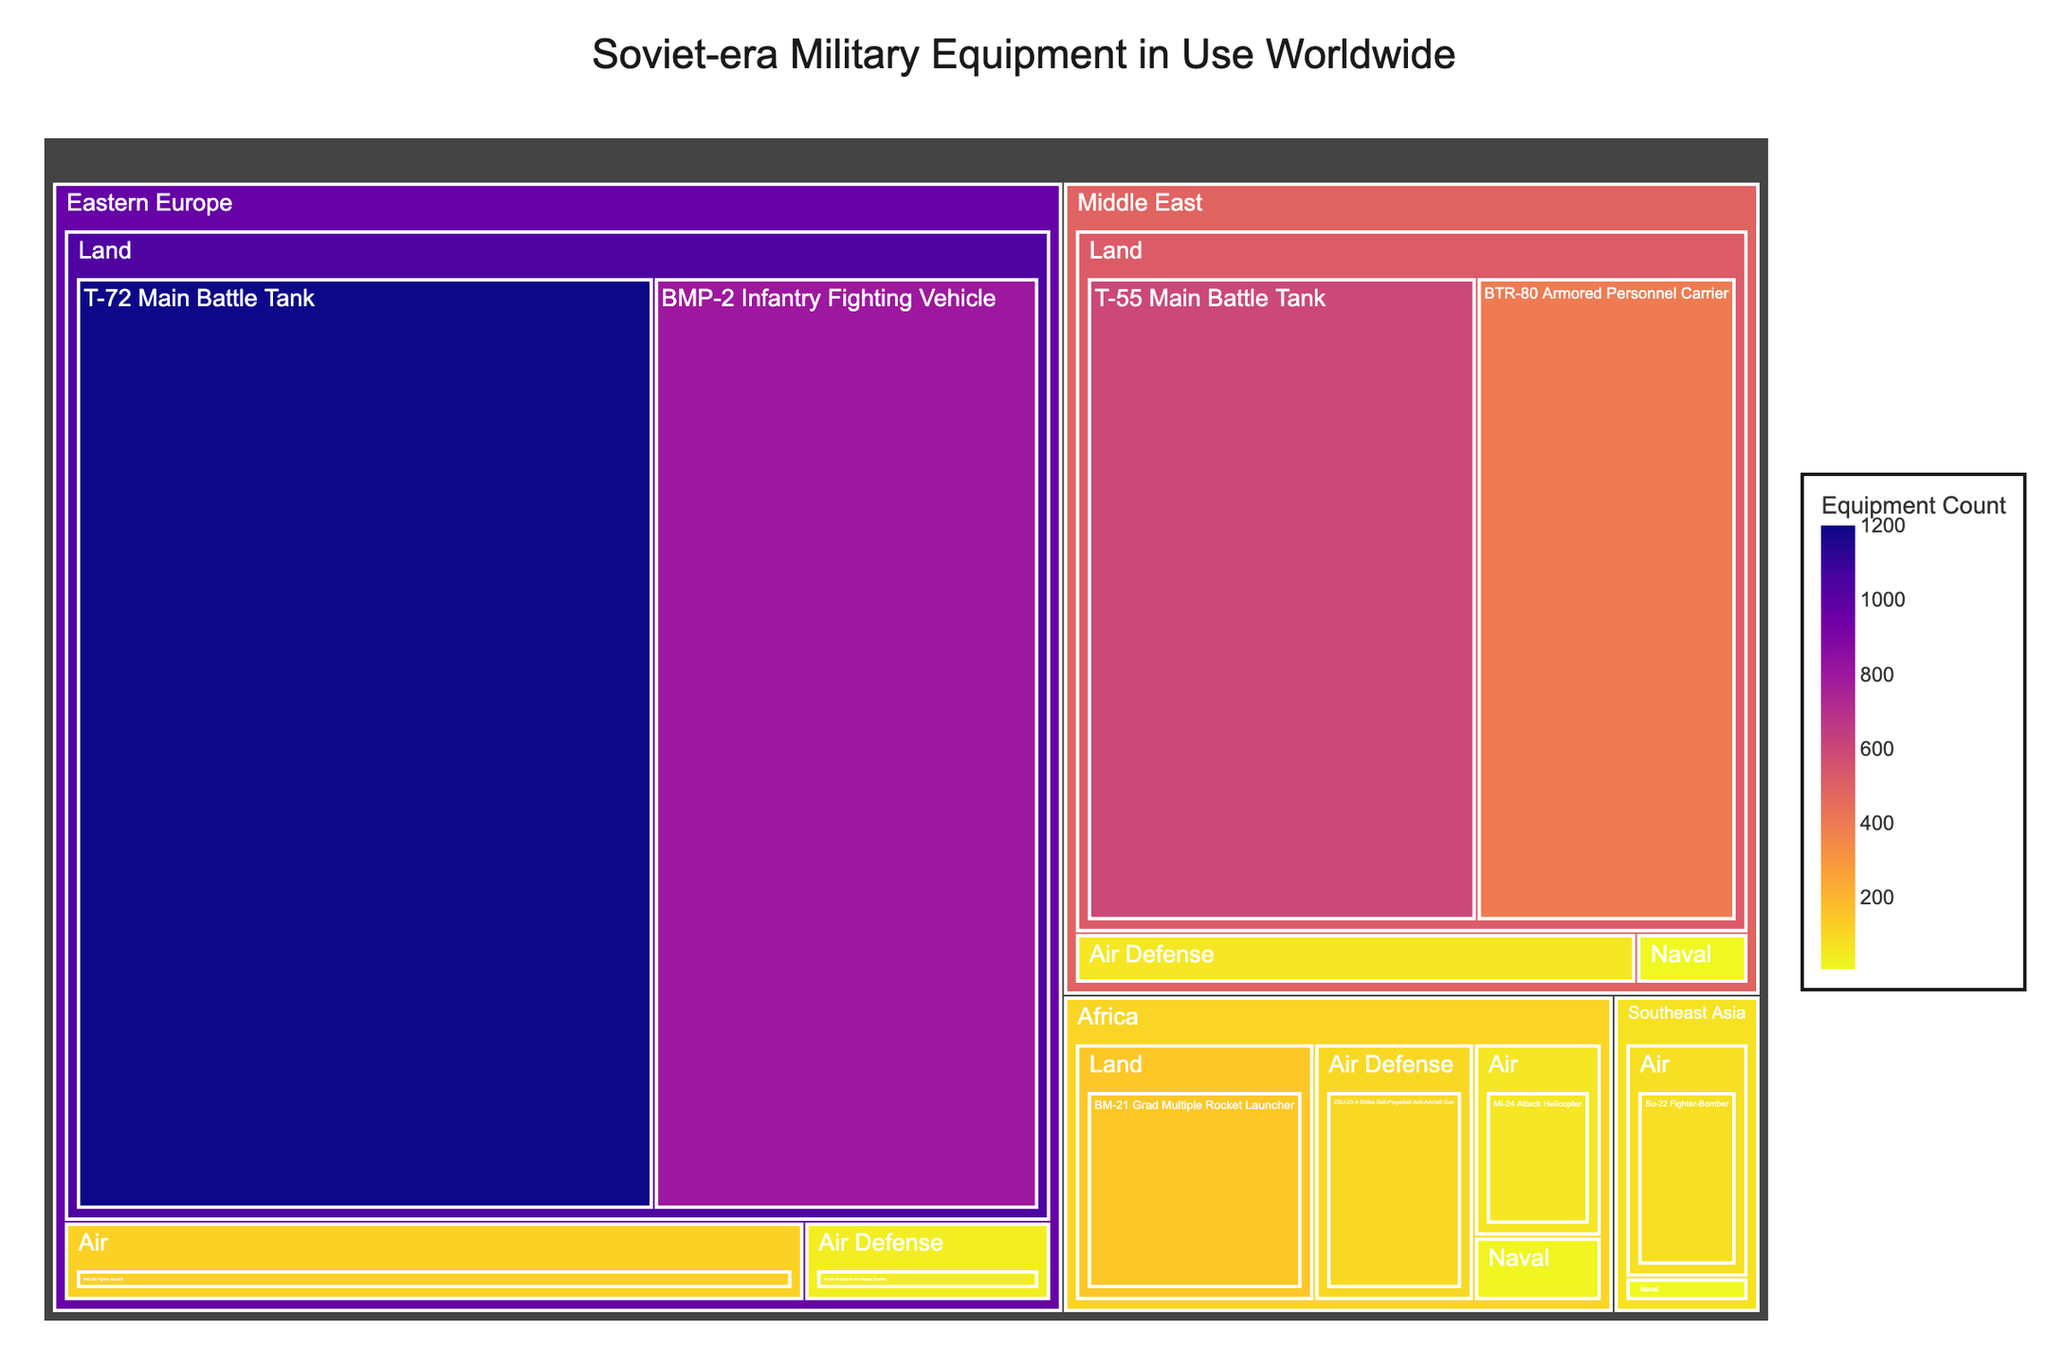What is the overall title of the figure? The title of the figure is usually displayed prominently at the top. Here, it states "Soviet-era Military Equipment in Use Worldwide".
Answer: Soviet-era Military Equipment in Use Worldwide Which region still uses the largest number of T-72 Main Battle Tanks? Locate the T-72 Main Battle Tank in the treemap under the Land type, and then identify the region associated with it. The region should be the largest segment related to this equipment.
Answer: Eastern Europe How many MiG-29 Fighter Aircrafts are still in use in Eastern Europe? Locate the Air type in the treemap, under Eastern Europe, and then find the MiG-29 Fighter Aircraft. The count associated with it will answer the question.
Answer: 120 What is the total count of Naval equipment in Africa? Add up the counts of all Naval equipment displayed under the Africa region. This includes Osa-class Missile Boat. The total is 20.
Answer: 20 Compare the number of S-300 Surface-to-Air Missile Systems in Eastern Europe to the 9K33 Osa Mobile SAM Systems in the Middle East. Which one is higher, and by how much? Locate the counts of both S-300 and 9K33 Osa on the treemap, then subtract the smaller from the larger to find the difference. S-300 is 40, and 9K33 Osa is 60. 60 - 40 = 20; thus, the 9K33 Osa count is higher by 20.
Answer: 9K33 Osa; by 20 Which type of equipment in Southeast Asia has the highest count? For the Southeast Asia region, identify the different equipment types and their respective counts. The Su-22 Fighter-Bomber has a count of 80, which is the highest in Southeast Asia.
Answer: Su-22 Fighter-Bomber What is the sum of all Air Defense equipment across all regions? Sum up the counts of all Air Defense equipment in the treemap: S-300 (40) from Eastern Europe, 9K33 Osa (60) from the Middle East, and ZSU-23-4 Shilka (100) from Africa. Total = 40 + 60 + 100 = 200.
Answer: 200 Based on the treemap, which region has the least amount of Soviet-era equipment still in use? Compare the sum of all equipment counts across all regions displayed on the treemap. The region with the smallest sum will be the one with the least equipment in use. The smallest sum appears to be in Southeast Asia.
Answer: Southeast Asia 